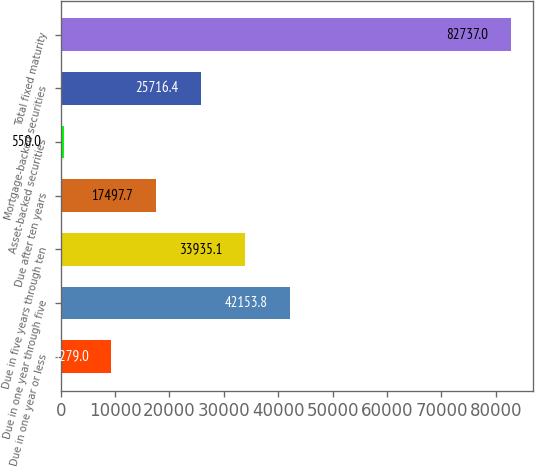Convert chart. <chart><loc_0><loc_0><loc_500><loc_500><bar_chart><fcel>Due in one year or less<fcel>Due in one year through five<fcel>Due in five years through ten<fcel>Due after ten years<fcel>Asset-backed securities<fcel>Mortgage-backed securities<fcel>Total fixed maturity<nl><fcel>9279<fcel>42153.8<fcel>33935.1<fcel>17497.7<fcel>550<fcel>25716.4<fcel>82737<nl></chart> 